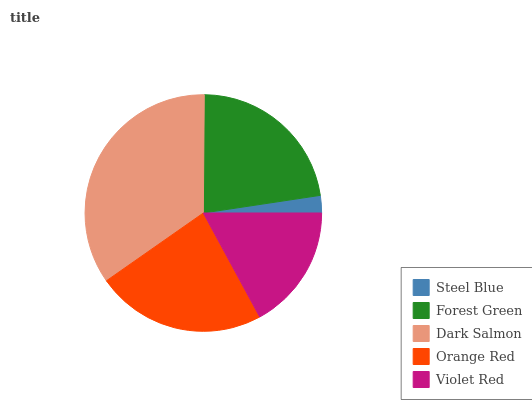Is Steel Blue the minimum?
Answer yes or no. Yes. Is Dark Salmon the maximum?
Answer yes or no. Yes. Is Forest Green the minimum?
Answer yes or no. No. Is Forest Green the maximum?
Answer yes or no. No. Is Forest Green greater than Steel Blue?
Answer yes or no. Yes. Is Steel Blue less than Forest Green?
Answer yes or no. Yes. Is Steel Blue greater than Forest Green?
Answer yes or no. No. Is Forest Green less than Steel Blue?
Answer yes or no. No. Is Forest Green the high median?
Answer yes or no. Yes. Is Forest Green the low median?
Answer yes or no. Yes. Is Dark Salmon the high median?
Answer yes or no. No. Is Violet Red the low median?
Answer yes or no. No. 